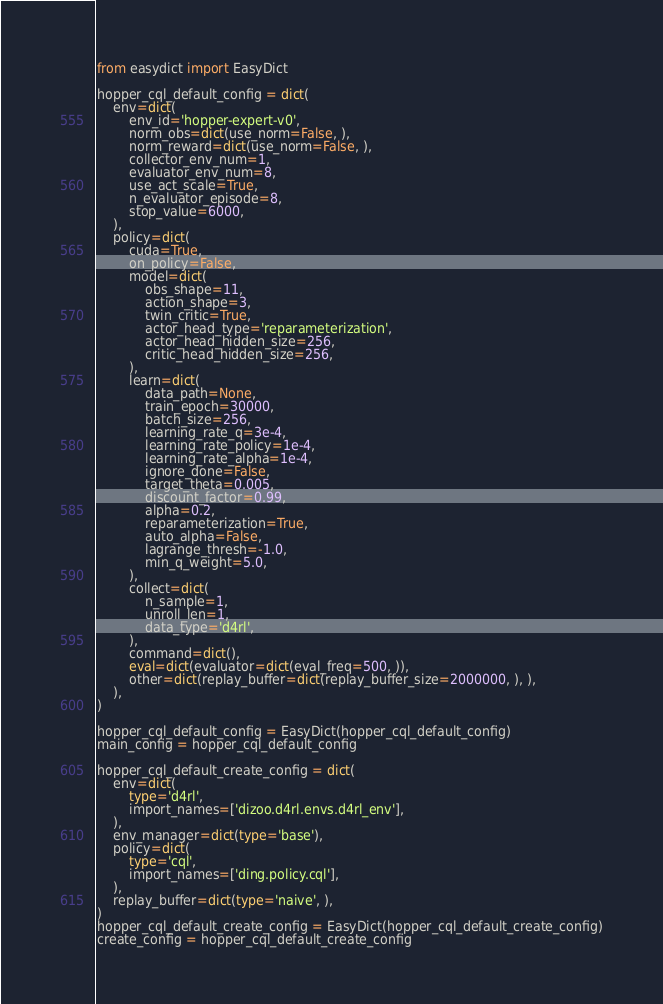Convert code to text. <code><loc_0><loc_0><loc_500><loc_500><_Python_>from easydict import EasyDict

hopper_cql_default_config = dict(
    env=dict(
        env_id='hopper-expert-v0',
        norm_obs=dict(use_norm=False, ),
        norm_reward=dict(use_norm=False, ),
        collector_env_num=1,
        evaluator_env_num=8,
        use_act_scale=True,
        n_evaluator_episode=8,
        stop_value=6000,
    ),
    policy=dict(
        cuda=True,
        on_policy=False,
        model=dict(
            obs_shape=11,
            action_shape=3,
            twin_critic=True,
            actor_head_type='reparameterization',
            actor_head_hidden_size=256,
            critic_head_hidden_size=256,
        ),
        learn=dict(
            data_path=None,
            train_epoch=30000,
            batch_size=256,
            learning_rate_q=3e-4,
            learning_rate_policy=1e-4,
            learning_rate_alpha=1e-4,
            ignore_done=False,
            target_theta=0.005,
            discount_factor=0.99,
            alpha=0.2,
            reparameterization=True,
            auto_alpha=False,
            lagrange_thresh=-1.0,
            min_q_weight=5.0,
        ),
        collect=dict(
            n_sample=1,
            unroll_len=1,
            data_type='d4rl',
        ),
        command=dict(),
        eval=dict(evaluator=dict(eval_freq=500, )),
        other=dict(replay_buffer=dict(replay_buffer_size=2000000, ), ),
    ),
)

hopper_cql_default_config = EasyDict(hopper_cql_default_config)
main_config = hopper_cql_default_config

hopper_cql_default_create_config = dict(
    env=dict(
        type='d4rl',
        import_names=['dizoo.d4rl.envs.d4rl_env'],
    ),
    env_manager=dict(type='base'),
    policy=dict(
        type='cql',
        import_names=['ding.policy.cql'],
    ),
    replay_buffer=dict(type='naive', ),
)
hopper_cql_default_create_config = EasyDict(hopper_cql_default_create_config)
create_config = hopper_cql_default_create_config
</code> 